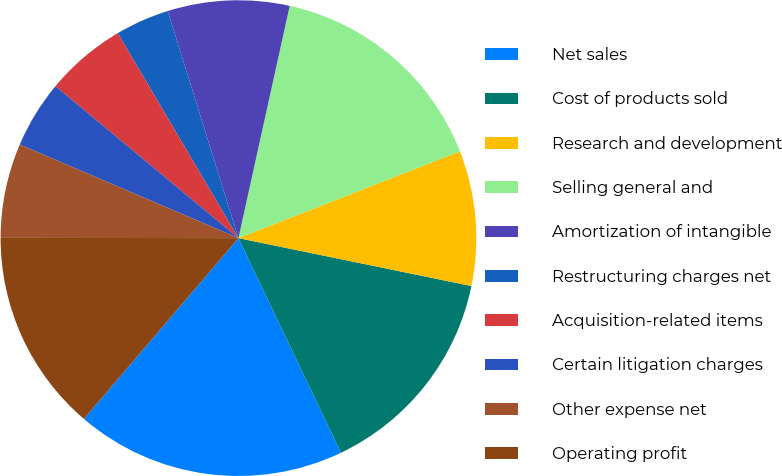<chart> <loc_0><loc_0><loc_500><loc_500><pie_chart><fcel>Net sales<fcel>Cost of products sold<fcel>Research and development<fcel>Selling general and<fcel>Amortization of intangible<fcel>Restructuring charges net<fcel>Acquisition-related items<fcel>Certain litigation charges<fcel>Other expense net<fcel>Operating profit<nl><fcel>18.35%<fcel>14.68%<fcel>9.17%<fcel>15.6%<fcel>8.26%<fcel>3.67%<fcel>5.5%<fcel>4.59%<fcel>6.42%<fcel>13.76%<nl></chart> 